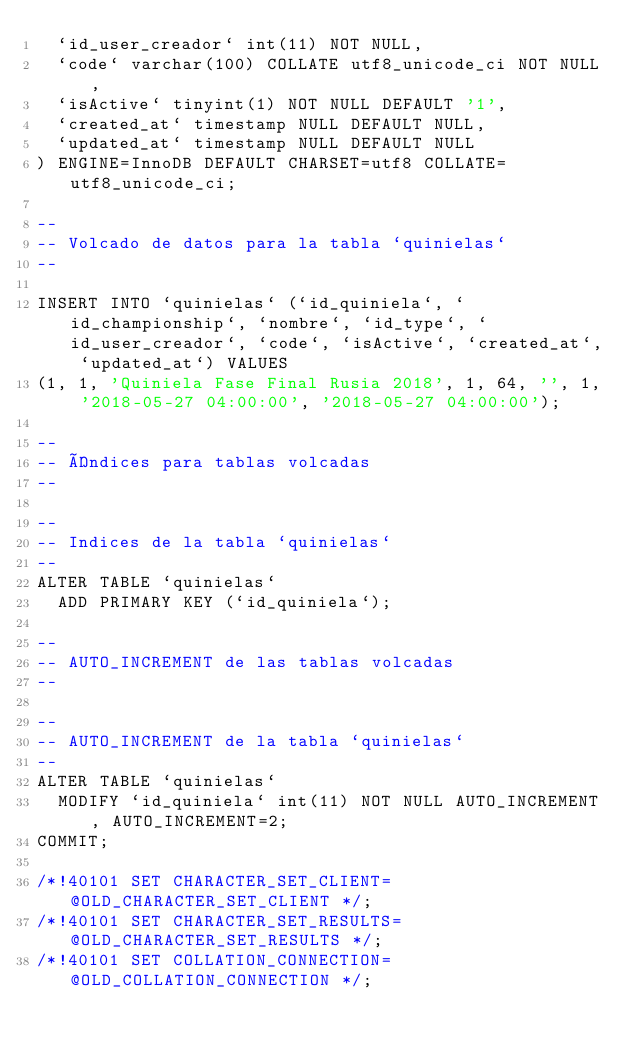<code> <loc_0><loc_0><loc_500><loc_500><_SQL_>  `id_user_creador` int(11) NOT NULL,
  `code` varchar(100) COLLATE utf8_unicode_ci NOT NULL,
  `isActive` tinyint(1) NOT NULL DEFAULT '1',
  `created_at` timestamp NULL DEFAULT NULL,
  `updated_at` timestamp NULL DEFAULT NULL
) ENGINE=InnoDB DEFAULT CHARSET=utf8 COLLATE=utf8_unicode_ci;

--
-- Volcado de datos para la tabla `quinielas`
--

INSERT INTO `quinielas` (`id_quiniela`, `id_championship`, `nombre`, `id_type`, `id_user_creador`, `code`, `isActive`, `created_at`, `updated_at`) VALUES
(1, 1, 'Quiniela Fase Final Rusia 2018', 1, 64, '', 1, '2018-05-27 04:00:00', '2018-05-27 04:00:00');

--
-- Índices para tablas volcadas
--

--
-- Indices de la tabla `quinielas`
--
ALTER TABLE `quinielas`
  ADD PRIMARY KEY (`id_quiniela`);

--
-- AUTO_INCREMENT de las tablas volcadas
--

--
-- AUTO_INCREMENT de la tabla `quinielas`
--
ALTER TABLE `quinielas`
  MODIFY `id_quiniela` int(11) NOT NULL AUTO_INCREMENT, AUTO_INCREMENT=2;
COMMIT;

/*!40101 SET CHARACTER_SET_CLIENT=@OLD_CHARACTER_SET_CLIENT */;
/*!40101 SET CHARACTER_SET_RESULTS=@OLD_CHARACTER_SET_RESULTS */;
/*!40101 SET COLLATION_CONNECTION=@OLD_COLLATION_CONNECTION */;
</code> 